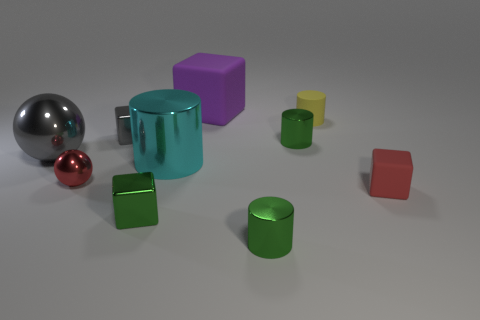There is a rubber cylinder that is to the right of the large purple matte object; how big is it?
Give a very brief answer. Small. The other big thing that is the same material as the cyan thing is what shape?
Ensure brevity in your answer.  Sphere. Are the red cube and the red thing to the left of the tiny red rubber cube made of the same material?
Your answer should be compact. No. There is a green object that is left of the large block; is it the same shape as the tiny red rubber thing?
Make the answer very short. Yes. There is a purple object that is the same shape as the tiny gray thing; what is its material?
Your response must be concise. Rubber. Is the shape of the tiny yellow matte object the same as the small gray shiny thing left of the tiny red rubber block?
Your answer should be very brief. No. The object that is both in front of the tiny red block and left of the cyan thing is what color?
Offer a terse response. Green. Are any large metal objects visible?
Your answer should be very brief. Yes. Are there an equal number of tiny rubber cubes on the left side of the tiny yellow rubber thing and tiny gray rubber blocks?
Provide a succinct answer. Yes. How many other objects are there of the same shape as the big cyan shiny object?
Provide a short and direct response. 3. 